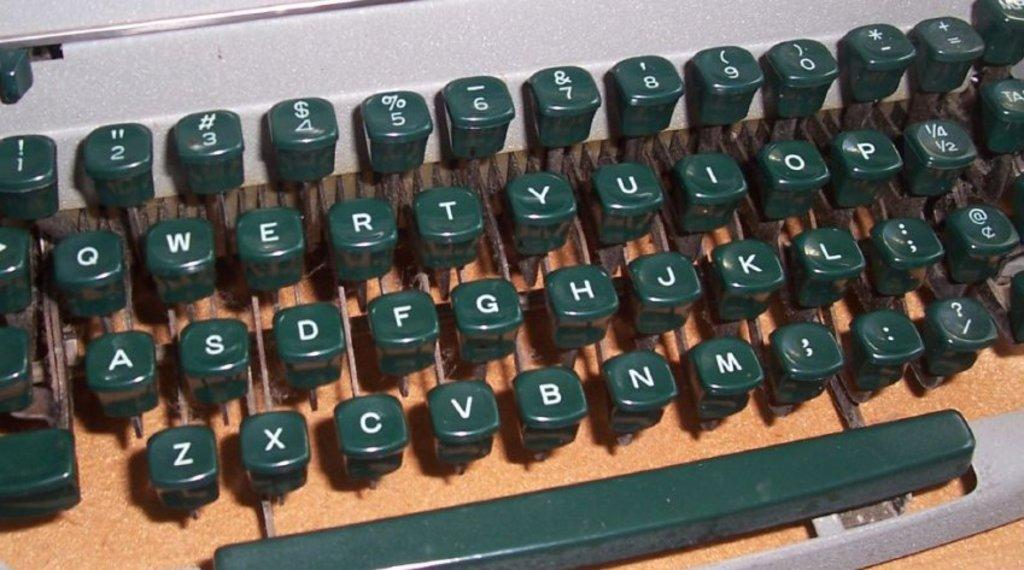<image>
Render a clear and concise summary of the photo. A type writer keyboard with the letters of the alphabet on them. 